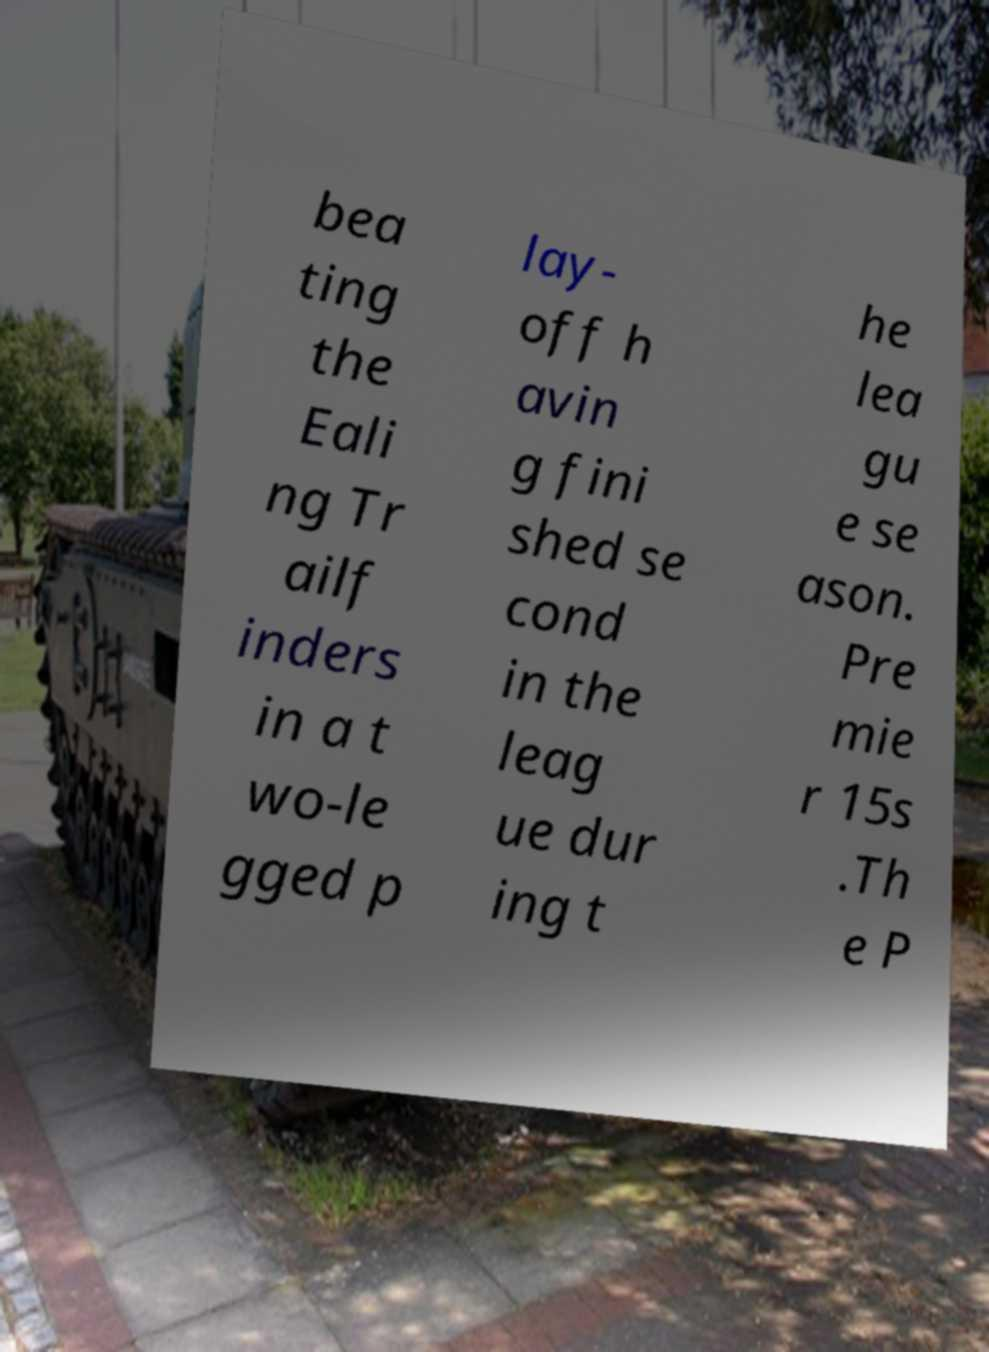For documentation purposes, I need the text within this image transcribed. Could you provide that? bea ting the Eali ng Tr ailf inders in a t wo-le gged p lay- off h avin g fini shed se cond in the leag ue dur ing t he lea gu e se ason. Pre mie r 15s .Th e P 